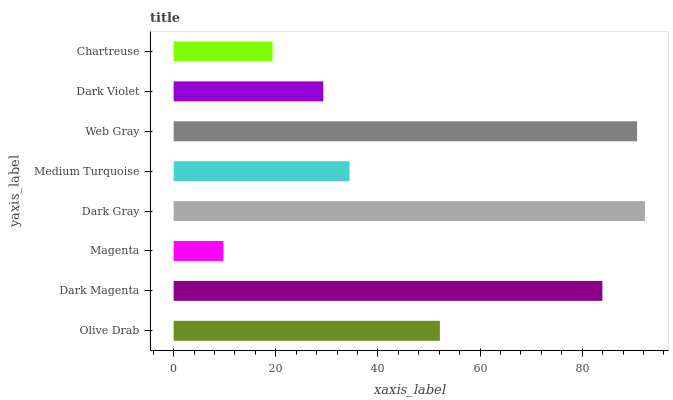Is Magenta the minimum?
Answer yes or no. Yes. Is Dark Gray the maximum?
Answer yes or no. Yes. Is Dark Magenta the minimum?
Answer yes or no. No. Is Dark Magenta the maximum?
Answer yes or no. No. Is Dark Magenta greater than Olive Drab?
Answer yes or no. Yes. Is Olive Drab less than Dark Magenta?
Answer yes or no. Yes. Is Olive Drab greater than Dark Magenta?
Answer yes or no. No. Is Dark Magenta less than Olive Drab?
Answer yes or no. No. Is Olive Drab the high median?
Answer yes or no. Yes. Is Medium Turquoise the low median?
Answer yes or no. Yes. Is Dark Violet the high median?
Answer yes or no. No. Is Magenta the low median?
Answer yes or no. No. 